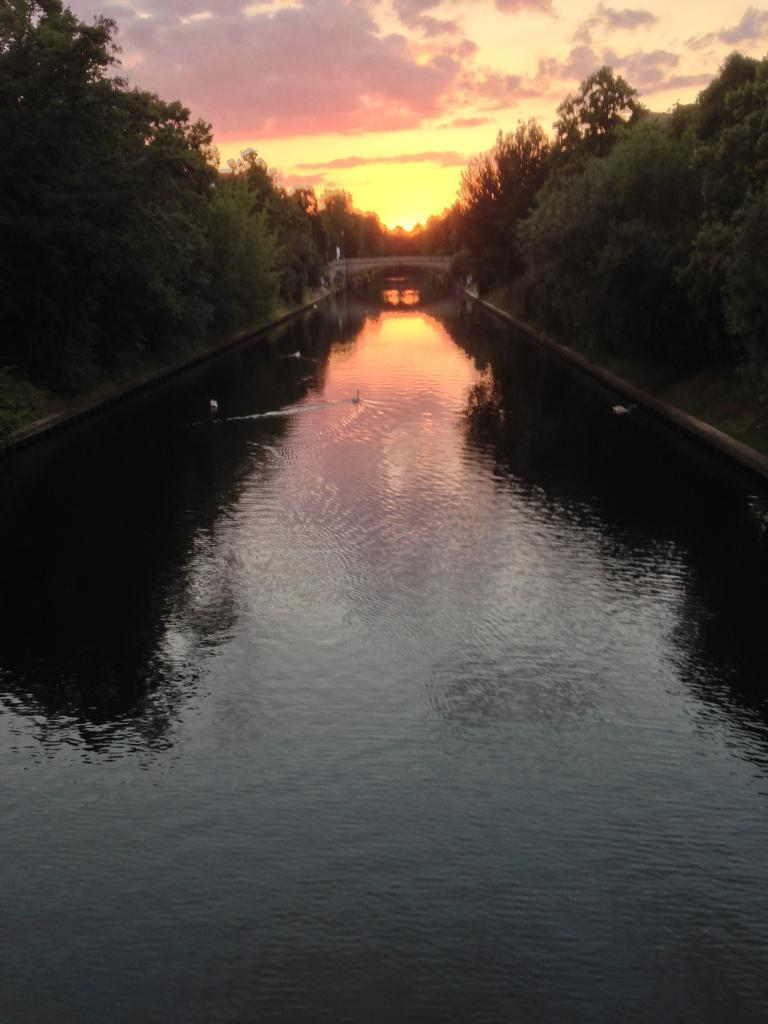What is located in the foreground of the image? There is a canal in the foreground of the image. What type of vegetation is present alongside the canal? Trees are present on either side of the canal. What can be seen in the background of the image? The background of the image includes a sunset and the sky. What else is visible in the sky? Clouds are present in the sky. How many children are waving good-bye in the image? There are no children present in the image, nor is anyone waving good-bye. What type of riddle can be solved using the image? The image does not contain any elements that would allow for the solving of a riddle. 